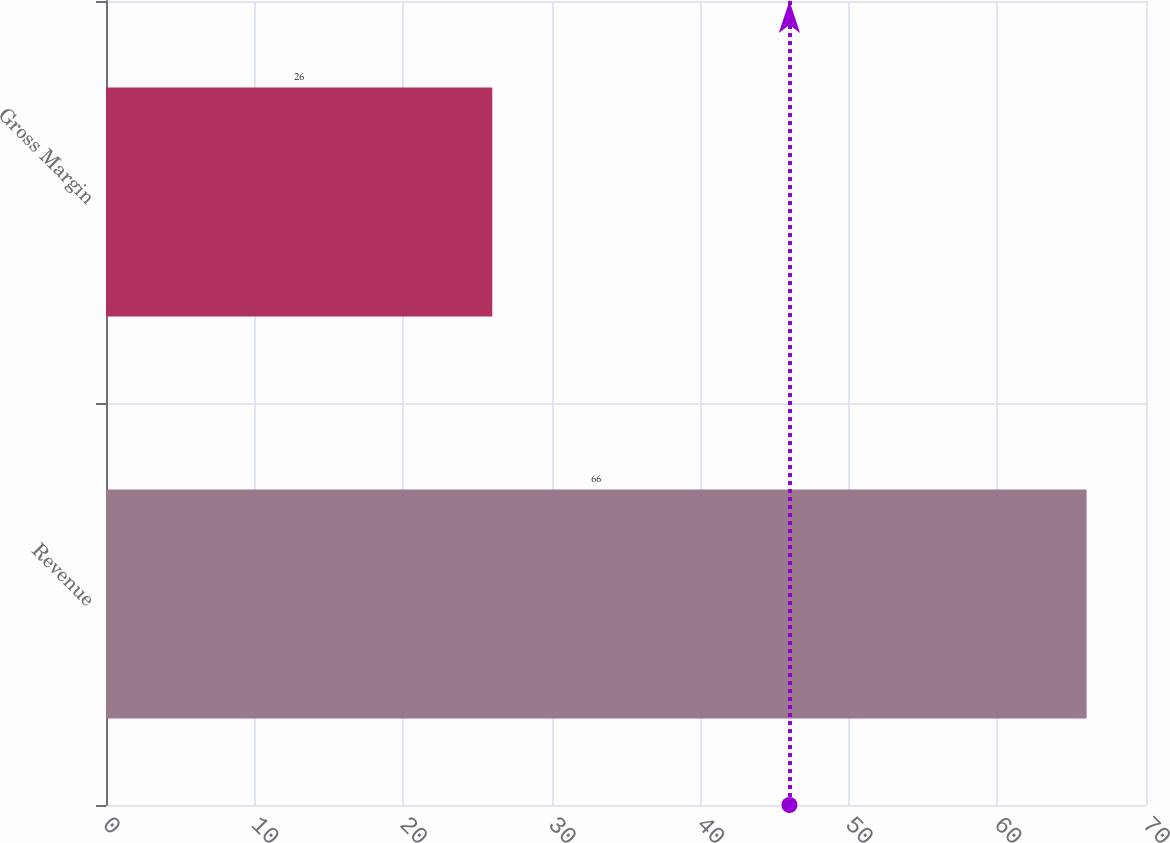<chart> <loc_0><loc_0><loc_500><loc_500><bar_chart><fcel>Revenue<fcel>Gross Margin<nl><fcel>66<fcel>26<nl></chart> 